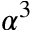Convert formula to latex. <formula><loc_0><loc_0><loc_500><loc_500>\alpha ^ { 3 }</formula> 